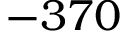Convert formula to latex. <formula><loc_0><loc_0><loc_500><loc_500>- 3 7 0</formula> 